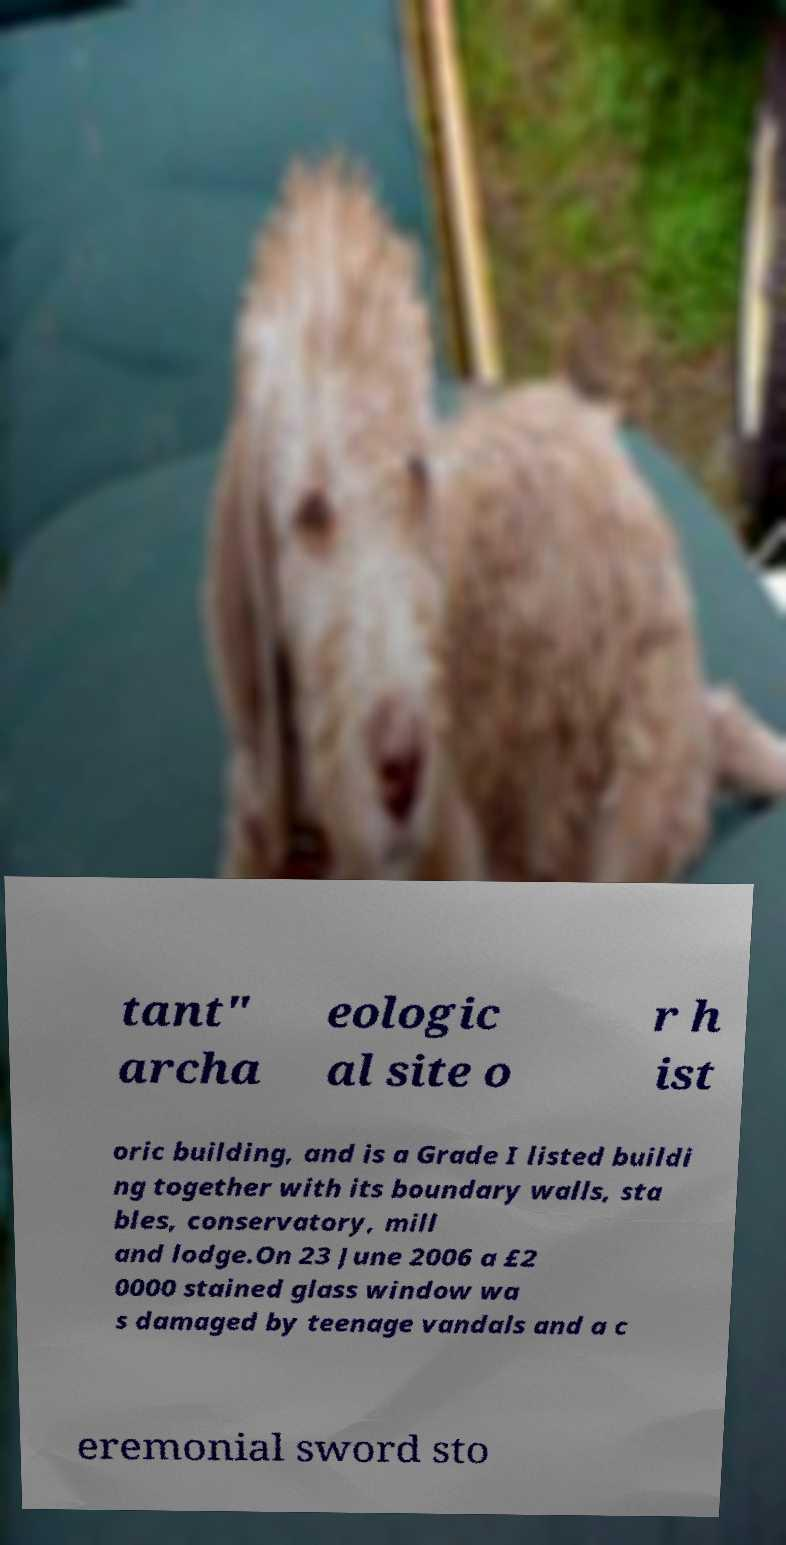Can you accurately transcribe the text from the provided image for me? tant" archa eologic al site o r h ist oric building, and is a Grade I listed buildi ng together with its boundary walls, sta bles, conservatory, mill and lodge.On 23 June 2006 a £2 0000 stained glass window wa s damaged by teenage vandals and a c eremonial sword sto 